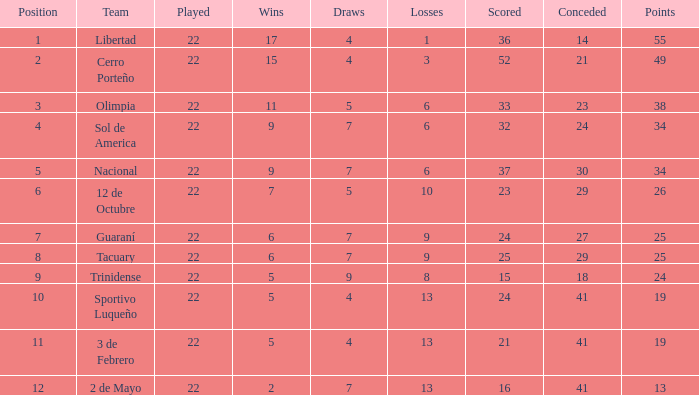Help me parse the entirety of this table. {'header': ['Position', 'Team', 'Played', 'Wins', 'Draws', 'Losses', 'Scored', 'Conceded', 'Points'], 'rows': [['1', 'Libertad', '22', '17', '4', '1', '36', '14', '55'], ['2', 'Cerro Porteño', '22', '15', '4', '3', '52', '21', '49'], ['3', 'Olimpia', '22', '11', '5', '6', '33', '23', '38'], ['4', 'Sol de America', '22', '9', '7', '6', '32', '24', '34'], ['5', 'Nacional', '22', '9', '7', '6', '37', '30', '34'], ['6', '12 de Octubre', '22', '7', '5', '10', '23', '29', '26'], ['7', 'Guaraní', '22', '6', '7', '9', '24', '27', '25'], ['8', 'Tacuary', '22', '6', '7', '9', '25', '29', '25'], ['9', 'Trinidense', '22', '5', '9', '8', '15', '18', '24'], ['10', 'Sportivo Luqueño', '22', '5', '4', '13', '24', '41', '19'], ['11', '3 de Febrero', '22', '5', '4', '13', '21', '41', '19'], ['12', '2 de Mayo', '22', '2', '7', '13', '16', '41', '13']]} What is the least number of wins having below 23 goals scored, 2 de mayo squad, and fewer than 7 ties? None. 